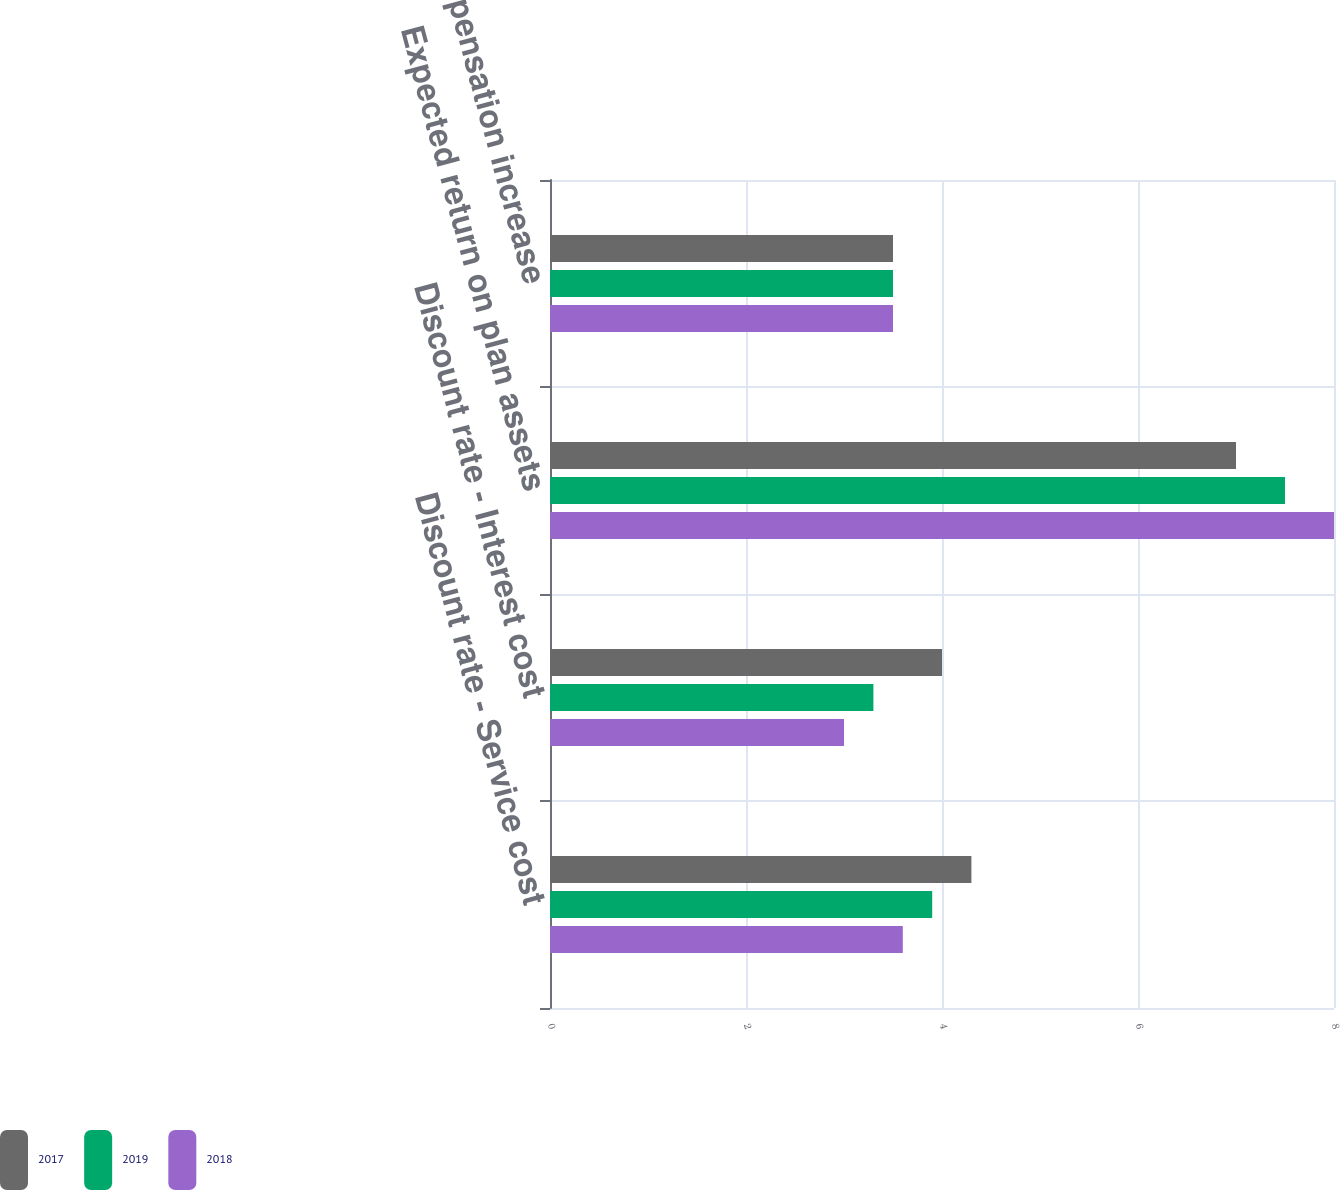Convert chart to OTSL. <chart><loc_0><loc_0><loc_500><loc_500><stacked_bar_chart><ecel><fcel>Discount rate - Service cost<fcel>Discount rate - Interest cost<fcel>Expected return on plan assets<fcel>Rate of compensation increase<nl><fcel>2017<fcel>4.3<fcel>4<fcel>7<fcel>3.5<nl><fcel>2019<fcel>3.9<fcel>3.3<fcel>7.5<fcel>3.5<nl><fcel>2018<fcel>3.6<fcel>3<fcel>8<fcel>3.5<nl></chart> 